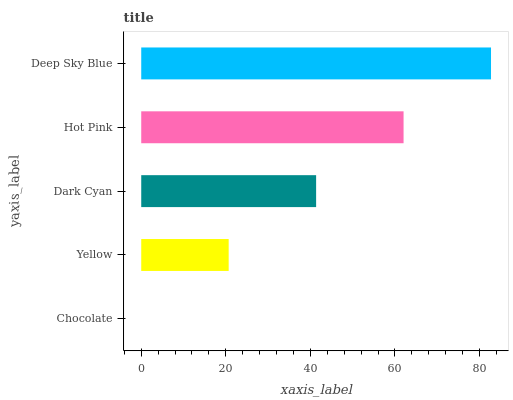Is Chocolate the minimum?
Answer yes or no. Yes. Is Deep Sky Blue the maximum?
Answer yes or no. Yes. Is Yellow the minimum?
Answer yes or no. No. Is Yellow the maximum?
Answer yes or no. No. Is Yellow greater than Chocolate?
Answer yes or no. Yes. Is Chocolate less than Yellow?
Answer yes or no. Yes. Is Chocolate greater than Yellow?
Answer yes or no. No. Is Yellow less than Chocolate?
Answer yes or no. No. Is Dark Cyan the high median?
Answer yes or no. Yes. Is Dark Cyan the low median?
Answer yes or no. Yes. Is Deep Sky Blue the high median?
Answer yes or no. No. Is Chocolate the low median?
Answer yes or no. No. 